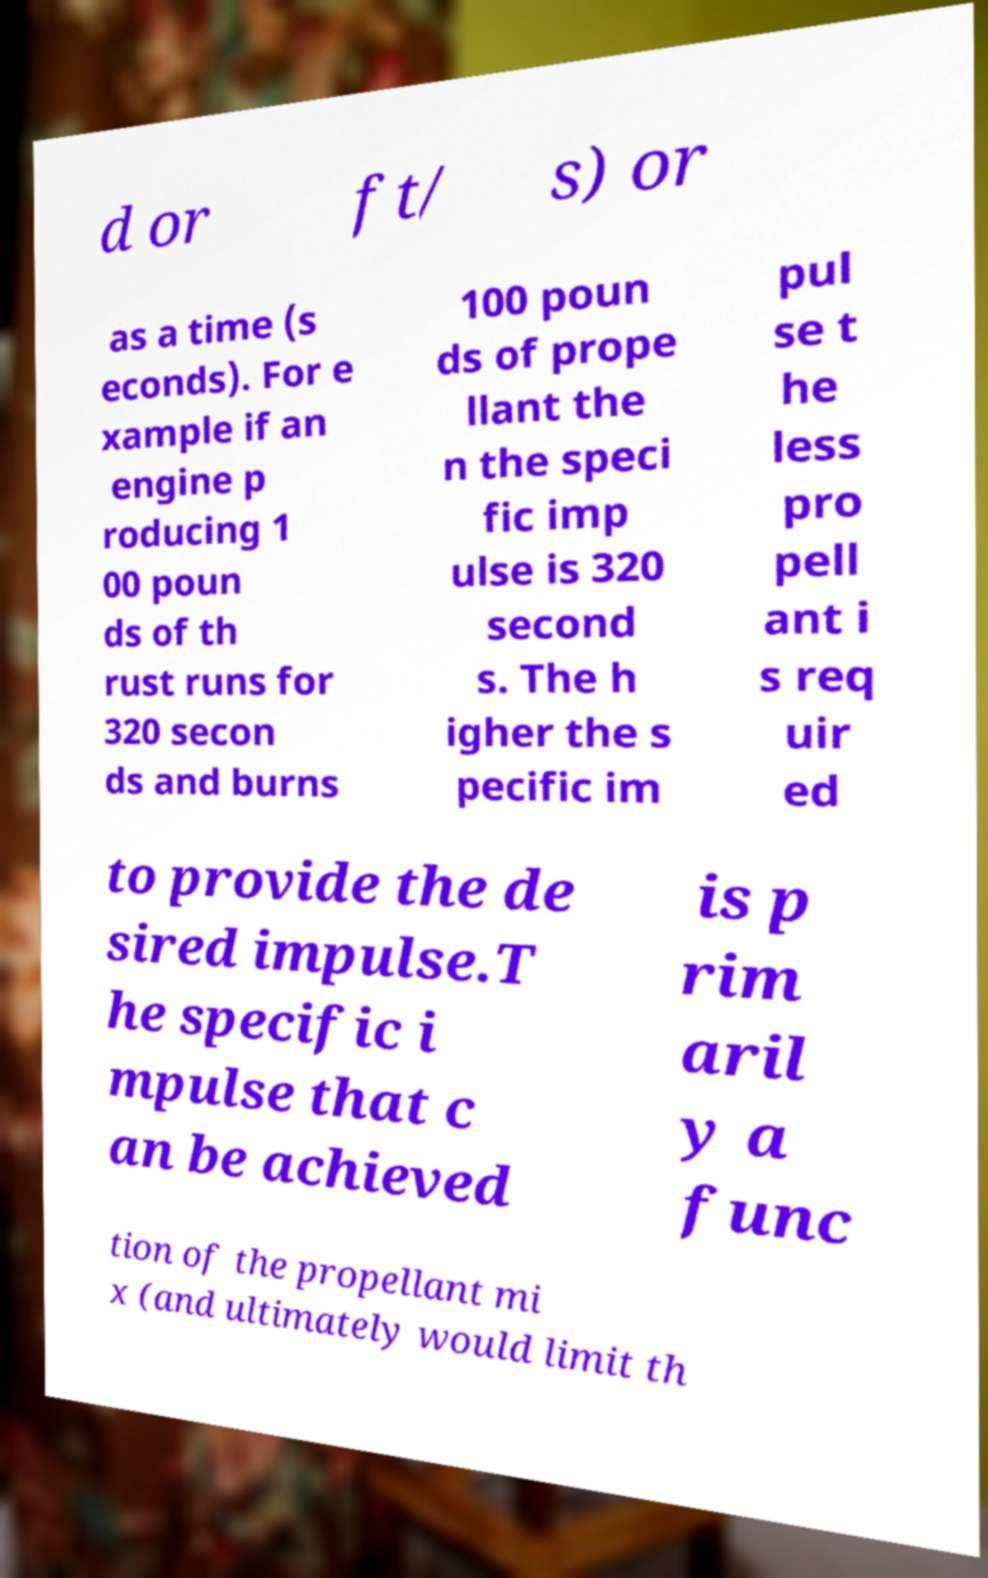Can you accurately transcribe the text from the provided image for me? d or ft/ s) or as a time (s econds). For e xample if an engine p roducing 1 00 poun ds of th rust runs for 320 secon ds and burns 100 poun ds of prope llant the n the speci fic imp ulse is 320 second s. The h igher the s pecific im pul se t he less pro pell ant i s req uir ed to provide the de sired impulse.T he specific i mpulse that c an be achieved is p rim aril y a func tion of the propellant mi x (and ultimately would limit th 